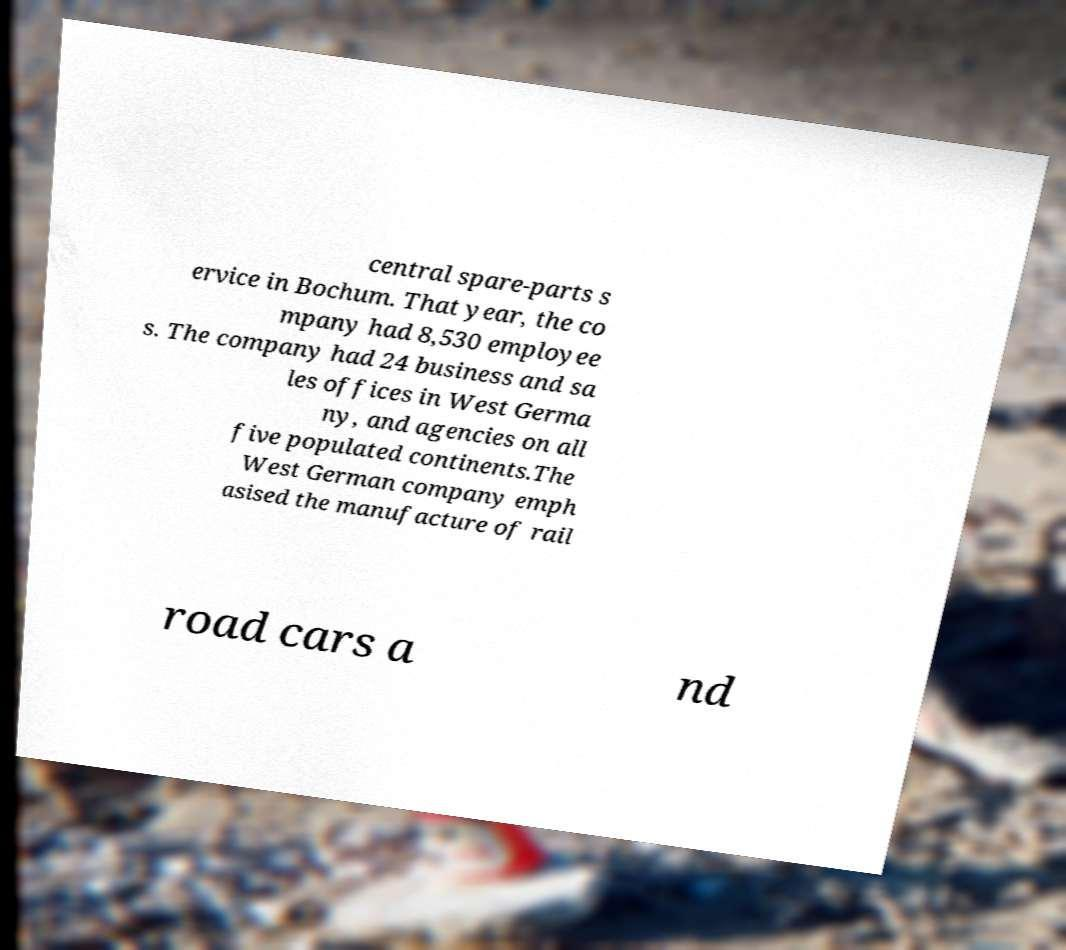Could you assist in decoding the text presented in this image and type it out clearly? central spare-parts s ervice in Bochum. That year, the co mpany had 8,530 employee s. The company had 24 business and sa les offices in West Germa ny, and agencies on all five populated continents.The West German company emph asised the manufacture of rail road cars a nd 